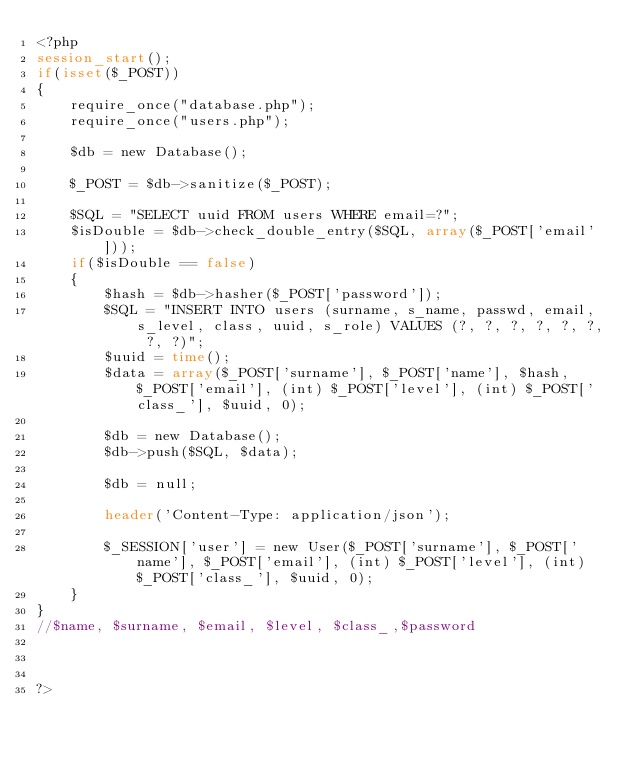<code> <loc_0><loc_0><loc_500><loc_500><_PHP_><?php
session_start();
if(isset($_POST))
{
    require_once("database.php");
    require_once("users.php");

    $db = new Database();

    $_POST = $db->sanitize($_POST);

    $SQL = "SELECT uuid FROM users WHERE email=?";
    $isDouble = $db->check_double_entry($SQL, array($_POST['email']));
    if($isDouble == false)
    {
        $hash = $db->hasher($_POST['password']);
        $SQL = "INSERT INTO users (surname, s_name, passwd, email, s_level, class, uuid, s_role) VALUES (?, ?, ?, ?, ?, ?, ?, ?)";
        $uuid = time();
        $data = array($_POST['surname'], $_POST['name'], $hash, $_POST['email'], (int) $_POST['level'], (int) $_POST['class_'], $uuid, 0);

        $db = new Database();
        $db->push($SQL, $data);

        $db = null;

        header('Content-Type: application/json');

        $_SESSION['user'] = new User($_POST['surname'], $_POST['name'], $_POST['email'], (int) $_POST['level'], (int) $_POST['class_'], $uuid, 0);
    }
}
//$name, $surname, $email, $level, $class_,$password



?></code> 